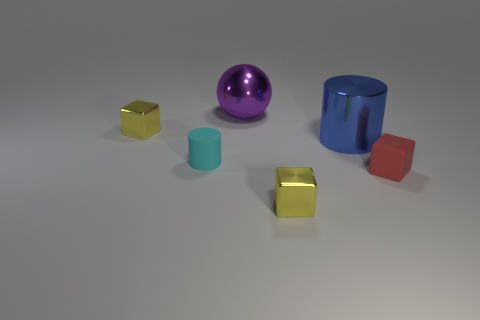Is the number of large purple metallic things greater than the number of small yellow spheres?
Offer a very short reply. Yes. What number of big objects are either gray blocks or blue cylinders?
Keep it short and to the point. 1. What number of other things are there of the same color as the tiny matte cylinder?
Provide a succinct answer. 0. What number of tiny red blocks have the same material as the large purple thing?
Make the answer very short. 0. There is a tiny cylinder to the left of the shiny ball; is it the same color as the big shiny sphere?
Provide a succinct answer. No. What number of gray things are either small objects or big cylinders?
Keep it short and to the point. 0. Is there any other thing that has the same material as the small red object?
Your answer should be very brief. Yes. Does the cylinder that is to the right of the purple metal thing have the same material as the cyan thing?
Your response must be concise. No. How many objects are purple spheres or tiny matte blocks that are in front of the small cyan cylinder?
Your answer should be compact. 2. There is a yellow shiny cube that is behind the matte thing that is to the right of the tiny matte cylinder; how many shiny spheres are left of it?
Make the answer very short. 0. 